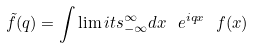<formula> <loc_0><loc_0><loc_500><loc_500>\tilde { f } ( q ) = \int \lim i t s _ { - \infty } ^ { \infty } d x \ e ^ { i q x } \ f ( x )</formula> 